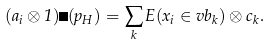<formula> <loc_0><loc_0><loc_500><loc_500>( a _ { i } \otimes 1 ) \Delta ( p _ { H } ) = \sum _ { k } E ( x _ { i } \in v b _ { k } ) \otimes c _ { k } .</formula> 